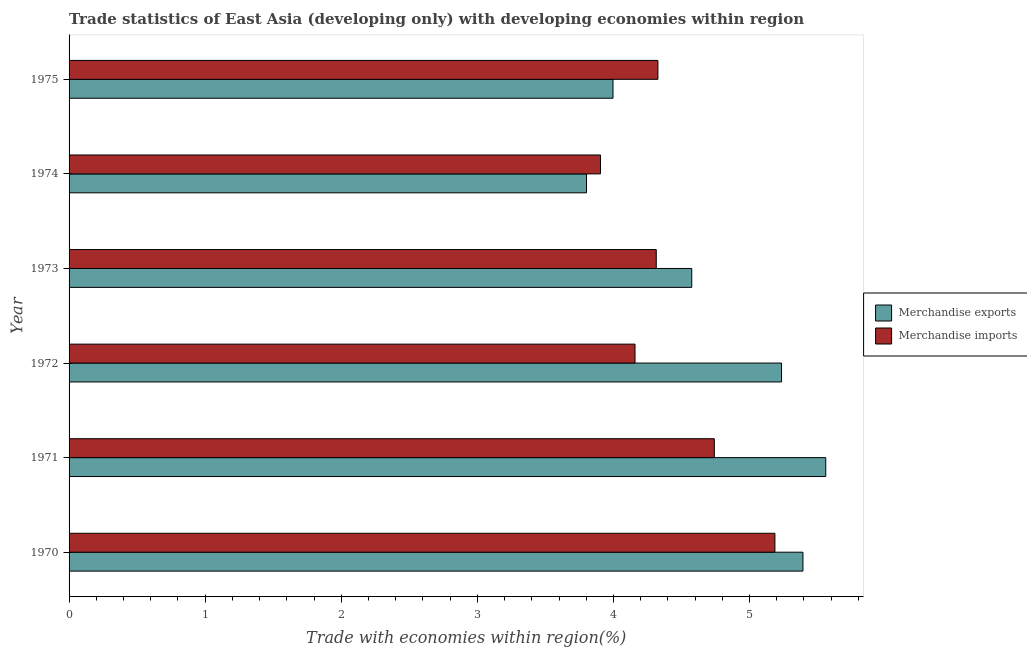How many different coloured bars are there?
Provide a short and direct response. 2. In how many cases, is the number of bars for a given year not equal to the number of legend labels?
Provide a succinct answer. 0. What is the merchandise imports in 1972?
Provide a succinct answer. 4.16. Across all years, what is the maximum merchandise exports?
Your response must be concise. 5.56. Across all years, what is the minimum merchandise exports?
Offer a terse response. 3.8. In which year was the merchandise exports minimum?
Offer a terse response. 1974. What is the total merchandise exports in the graph?
Provide a succinct answer. 28.56. What is the difference between the merchandise imports in 1970 and that in 1972?
Your response must be concise. 1.03. What is the difference between the merchandise exports in 1972 and the merchandise imports in 1973?
Provide a short and direct response. 0.92. What is the average merchandise exports per year?
Your response must be concise. 4.76. In the year 1974, what is the difference between the merchandise imports and merchandise exports?
Offer a terse response. 0.1. What is the ratio of the merchandise imports in 1971 to that in 1973?
Your answer should be very brief. 1.1. Is the difference between the merchandise imports in 1974 and 1975 greater than the difference between the merchandise exports in 1974 and 1975?
Provide a succinct answer. No. What is the difference between the highest and the second highest merchandise exports?
Your answer should be very brief. 0.17. What is the difference between the highest and the lowest merchandise imports?
Make the answer very short. 1.28. In how many years, is the merchandise imports greater than the average merchandise imports taken over all years?
Provide a short and direct response. 2. Is the sum of the merchandise imports in 1970 and 1974 greater than the maximum merchandise exports across all years?
Give a very brief answer. Yes. What does the 2nd bar from the top in 1971 represents?
Provide a short and direct response. Merchandise exports. How many bars are there?
Your response must be concise. 12. Are all the bars in the graph horizontal?
Make the answer very short. Yes. How many years are there in the graph?
Ensure brevity in your answer.  6. Does the graph contain any zero values?
Provide a short and direct response. No. Does the graph contain grids?
Offer a terse response. No. Where does the legend appear in the graph?
Offer a very short reply. Center right. What is the title of the graph?
Provide a succinct answer. Trade statistics of East Asia (developing only) with developing economies within region. Does "Rural Population" appear as one of the legend labels in the graph?
Offer a very short reply. No. What is the label or title of the X-axis?
Your response must be concise. Trade with economies within region(%). What is the Trade with economies within region(%) of Merchandise exports in 1970?
Offer a very short reply. 5.39. What is the Trade with economies within region(%) in Merchandise imports in 1970?
Give a very brief answer. 5.19. What is the Trade with economies within region(%) in Merchandise exports in 1971?
Provide a succinct answer. 5.56. What is the Trade with economies within region(%) of Merchandise imports in 1971?
Your answer should be compact. 4.74. What is the Trade with economies within region(%) of Merchandise exports in 1972?
Make the answer very short. 5.24. What is the Trade with economies within region(%) of Merchandise imports in 1972?
Provide a short and direct response. 4.16. What is the Trade with economies within region(%) of Merchandise exports in 1973?
Provide a short and direct response. 4.58. What is the Trade with economies within region(%) of Merchandise imports in 1973?
Your answer should be very brief. 4.31. What is the Trade with economies within region(%) in Merchandise exports in 1974?
Make the answer very short. 3.8. What is the Trade with economies within region(%) of Merchandise imports in 1974?
Provide a succinct answer. 3.91. What is the Trade with economies within region(%) of Merchandise exports in 1975?
Your answer should be compact. 4. What is the Trade with economies within region(%) in Merchandise imports in 1975?
Make the answer very short. 4.33. Across all years, what is the maximum Trade with economies within region(%) of Merchandise exports?
Make the answer very short. 5.56. Across all years, what is the maximum Trade with economies within region(%) in Merchandise imports?
Your response must be concise. 5.19. Across all years, what is the minimum Trade with economies within region(%) in Merchandise exports?
Keep it short and to the point. 3.8. Across all years, what is the minimum Trade with economies within region(%) in Merchandise imports?
Make the answer very short. 3.91. What is the total Trade with economies within region(%) of Merchandise exports in the graph?
Make the answer very short. 28.56. What is the total Trade with economies within region(%) of Merchandise imports in the graph?
Offer a very short reply. 26.63. What is the difference between the Trade with economies within region(%) of Merchandise exports in 1970 and that in 1971?
Provide a short and direct response. -0.17. What is the difference between the Trade with economies within region(%) in Merchandise imports in 1970 and that in 1971?
Provide a succinct answer. 0.45. What is the difference between the Trade with economies within region(%) in Merchandise exports in 1970 and that in 1972?
Ensure brevity in your answer.  0.16. What is the difference between the Trade with economies within region(%) in Merchandise imports in 1970 and that in 1972?
Provide a short and direct response. 1.03. What is the difference between the Trade with economies within region(%) in Merchandise exports in 1970 and that in 1973?
Provide a succinct answer. 0.82. What is the difference between the Trade with economies within region(%) in Merchandise imports in 1970 and that in 1973?
Offer a terse response. 0.87. What is the difference between the Trade with economies within region(%) in Merchandise exports in 1970 and that in 1974?
Provide a succinct answer. 1.59. What is the difference between the Trade with economies within region(%) of Merchandise imports in 1970 and that in 1974?
Your answer should be very brief. 1.28. What is the difference between the Trade with economies within region(%) in Merchandise exports in 1970 and that in 1975?
Provide a short and direct response. 1.4. What is the difference between the Trade with economies within region(%) of Merchandise imports in 1970 and that in 1975?
Offer a very short reply. 0.86. What is the difference between the Trade with economies within region(%) in Merchandise exports in 1971 and that in 1972?
Offer a very short reply. 0.32. What is the difference between the Trade with economies within region(%) in Merchandise imports in 1971 and that in 1972?
Ensure brevity in your answer.  0.58. What is the difference between the Trade with economies within region(%) of Merchandise exports in 1971 and that in 1973?
Your response must be concise. 0.98. What is the difference between the Trade with economies within region(%) of Merchandise imports in 1971 and that in 1973?
Your answer should be very brief. 0.43. What is the difference between the Trade with economies within region(%) of Merchandise exports in 1971 and that in 1974?
Offer a very short reply. 1.76. What is the difference between the Trade with economies within region(%) of Merchandise imports in 1971 and that in 1974?
Provide a short and direct response. 0.84. What is the difference between the Trade with economies within region(%) in Merchandise exports in 1971 and that in 1975?
Keep it short and to the point. 1.56. What is the difference between the Trade with economies within region(%) of Merchandise imports in 1971 and that in 1975?
Provide a succinct answer. 0.41. What is the difference between the Trade with economies within region(%) in Merchandise exports in 1972 and that in 1973?
Give a very brief answer. 0.66. What is the difference between the Trade with economies within region(%) in Merchandise imports in 1972 and that in 1973?
Provide a short and direct response. -0.16. What is the difference between the Trade with economies within region(%) of Merchandise exports in 1972 and that in 1974?
Your answer should be very brief. 1.43. What is the difference between the Trade with economies within region(%) in Merchandise imports in 1972 and that in 1974?
Give a very brief answer. 0.25. What is the difference between the Trade with economies within region(%) of Merchandise exports in 1972 and that in 1975?
Offer a terse response. 1.24. What is the difference between the Trade with economies within region(%) in Merchandise imports in 1972 and that in 1975?
Keep it short and to the point. -0.17. What is the difference between the Trade with economies within region(%) of Merchandise exports in 1973 and that in 1974?
Your answer should be very brief. 0.77. What is the difference between the Trade with economies within region(%) in Merchandise imports in 1973 and that in 1974?
Provide a succinct answer. 0.41. What is the difference between the Trade with economies within region(%) in Merchandise exports in 1973 and that in 1975?
Provide a short and direct response. 0.58. What is the difference between the Trade with economies within region(%) in Merchandise imports in 1973 and that in 1975?
Your response must be concise. -0.01. What is the difference between the Trade with economies within region(%) in Merchandise exports in 1974 and that in 1975?
Provide a short and direct response. -0.19. What is the difference between the Trade with economies within region(%) in Merchandise imports in 1974 and that in 1975?
Provide a short and direct response. -0.42. What is the difference between the Trade with economies within region(%) of Merchandise exports in 1970 and the Trade with economies within region(%) of Merchandise imports in 1971?
Offer a very short reply. 0.65. What is the difference between the Trade with economies within region(%) of Merchandise exports in 1970 and the Trade with economies within region(%) of Merchandise imports in 1972?
Provide a short and direct response. 1.23. What is the difference between the Trade with economies within region(%) of Merchandise exports in 1970 and the Trade with economies within region(%) of Merchandise imports in 1973?
Your response must be concise. 1.08. What is the difference between the Trade with economies within region(%) in Merchandise exports in 1970 and the Trade with economies within region(%) in Merchandise imports in 1974?
Provide a short and direct response. 1.49. What is the difference between the Trade with economies within region(%) in Merchandise exports in 1970 and the Trade with economies within region(%) in Merchandise imports in 1975?
Give a very brief answer. 1.07. What is the difference between the Trade with economies within region(%) of Merchandise exports in 1971 and the Trade with economies within region(%) of Merchandise imports in 1972?
Give a very brief answer. 1.4. What is the difference between the Trade with economies within region(%) in Merchandise exports in 1971 and the Trade with economies within region(%) in Merchandise imports in 1973?
Offer a terse response. 1.25. What is the difference between the Trade with economies within region(%) of Merchandise exports in 1971 and the Trade with economies within region(%) of Merchandise imports in 1974?
Provide a short and direct response. 1.66. What is the difference between the Trade with economies within region(%) of Merchandise exports in 1971 and the Trade with economies within region(%) of Merchandise imports in 1975?
Make the answer very short. 1.23. What is the difference between the Trade with economies within region(%) of Merchandise exports in 1972 and the Trade with economies within region(%) of Merchandise imports in 1973?
Provide a succinct answer. 0.92. What is the difference between the Trade with economies within region(%) of Merchandise exports in 1972 and the Trade with economies within region(%) of Merchandise imports in 1974?
Give a very brief answer. 1.33. What is the difference between the Trade with economies within region(%) in Merchandise exports in 1972 and the Trade with economies within region(%) in Merchandise imports in 1975?
Your response must be concise. 0.91. What is the difference between the Trade with economies within region(%) of Merchandise exports in 1973 and the Trade with economies within region(%) of Merchandise imports in 1974?
Keep it short and to the point. 0.67. What is the difference between the Trade with economies within region(%) in Merchandise exports in 1973 and the Trade with economies within region(%) in Merchandise imports in 1975?
Your response must be concise. 0.25. What is the difference between the Trade with economies within region(%) in Merchandise exports in 1974 and the Trade with economies within region(%) in Merchandise imports in 1975?
Your answer should be compact. -0.52. What is the average Trade with economies within region(%) of Merchandise exports per year?
Provide a short and direct response. 4.76. What is the average Trade with economies within region(%) in Merchandise imports per year?
Make the answer very short. 4.44. In the year 1970, what is the difference between the Trade with economies within region(%) of Merchandise exports and Trade with economies within region(%) of Merchandise imports?
Give a very brief answer. 0.21. In the year 1971, what is the difference between the Trade with economies within region(%) in Merchandise exports and Trade with economies within region(%) in Merchandise imports?
Ensure brevity in your answer.  0.82. In the year 1972, what is the difference between the Trade with economies within region(%) in Merchandise exports and Trade with economies within region(%) in Merchandise imports?
Your answer should be compact. 1.08. In the year 1973, what is the difference between the Trade with economies within region(%) of Merchandise exports and Trade with economies within region(%) of Merchandise imports?
Ensure brevity in your answer.  0.26. In the year 1974, what is the difference between the Trade with economies within region(%) of Merchandise exports and Trade with economies within region(%) of Merchandise imports?
Ensure brevity in your answer.  -0.1. In the year 1975, what is the difference between the Trade with economies within region(%) of Merchandise exports and Trade with economies within region(%) of Merchandise imports?
Provide a short and direct response. -0.33. What is the ratio of the Trade with economies within region(%) of Merchandise exports in 1970 to that in 1971?
Keep it short and to the point. 0.97. What is the ratio of the Trade with economies within region(%) of Merchandise imports in 1970 to that in 1971?
Your answer should be very brief. 1.09. What is the ratio of the Trade with economies within region(%) in Merchandise exports in 1970 to that in 1972?
Keep it short and to the point. 1.03. What is the ratio of the Trade with economies within region(%) of Merchandise imports in 1970 to that in 1972?
Ensure brevity in your answer.  1.25. What is the ratio of the Trade with economies within region(%) of Merchandise exports in 1970 to that in 1973?
Your response must be concise. 1.18. What is the ratio of the Trade with economies within region(%) in Merchandise imports in 1970 to that in 1973?
Give a very brief answer. 1.2. What is the ratio of the Trade with economies within region(%) of Merchandise exports in 1970 to that in 1974?
Make the answer very short. 1.42. What is the ratio of the Trade with economies within region(%) in Merchandise imports in 1970 to that in 1974?
Offer a very short reply. 1.33. What is the ratio of the Trade with economies within region(%) of Merchandise exports in 1970 to that in 1975?
Give a very brief answer. 1.35. What is the ratio of the Trade with economies within region(%) in Merchandise imports in 1970 to that in 1975?
Provide a succinct answer. 1.2. What is the ratio of the Trade with economies within region(%) in Merchandise exports in 1971 to that in 1972?
Make the answer very short. 1.06. What is the ratio of the Trade with economies within region(%) in Merchandise imports in 1971 to that in 1972?
Your response must be concise. 1.14. What is the ratio of the Trade with economies within region(%) in Merchandise exports in 1971 to that in 1973?
Provide a short and direct response. 1.22. What is the ratio of the Trade with economies within region(%) of Merchandise imports in 1971 to that in 1973?
Ensure brevity in your answer.  1.1. What is the ratio of the Trade with economies within region(%) of Merchandise exports in 1971 to that in 1974?
Offer a terse response. 1.46. What is the ratio of the Trade with economies within region(%) of Merchandise imports in 1971 to that in 1974?
Make the answer very short. 1.21. What is the ratio of the Trade with economies within region(%) of Merchandise exports in 1971 to that in 1975?
Offer a terse response. 1.39. What is the ratio of the Trade with economies within region(%) of Merchandise imports in 1971 to that in 1975?
Ensure brevity in your answer.  1.1. What is the ratio of the Trade with economies within region(%) of Merchandise exports in 1972 to that in 1973?
Keep it short and to the point. 1.14. What is the ratio of the Trade with economies within region(%) of Merchandise imports in 1972 to that in 1973?
Your answer should be compact. 0.96. What is the ratio of the Trade with economies within region(%) of Merchandise exports in 1972 to that in 1974?
Make the answer very short. 1.38. What is the ratio of the Trade with economies within region(%) of Merchandise imports in 1972 to that in 1974?
Keep it short and to the point. 1.06. What is the ratio of the Trade with economies within region(%) of Merchandise exports in 1972 to that in 1975?
Make the answer very short. 1.31. What is the ratio of the Trade with economies within region(%) in Merchandise imports in 1972 to that in 1975?
Make the answer very short. 0.96. What is the ratio of the Trade with economies within region(%) of Merchandise exports in 1973 to that in 1974?
Ensure brevity in your answer.  1.2. What is the ratio of the Trade with economies within region(%) of Merchandise imports in 1973 to that in 1974?
Your answer should be compact. 1.1. What is the ratio of the Trade with economies within region(%) in Merchandise exports in 1973 to that in 1975?
Offer a very short reply. 1.14. What is the ratio of the Trade with economies within region(%) in Merchandise exports in 1974 to that in 1975?
Your answer should be compact. 0.95. What is the ratio of the Trade with economies within region(%) of Merchandise imports in 1974 to that in 1975?
Offer a very short reply. 0.9. What is the difference between the highest and the second highest Trade with economies within region(%) in Merchandise exports?
Your response must be concise. 0.17. What is the difference between the highest and the second highest Trade with economies within region(%) in Merchandise imports?
Your response must be concise. 0.45. What is the difference between the highest and the lowest Trade with economies within region(%) of Merchandise exports?
Your answer should be compact. 1.76. What is the difference between the highest and the lowest Trade with economies within region(%) in Merchandise imports?
Keep it short and to the point. 1.28. 